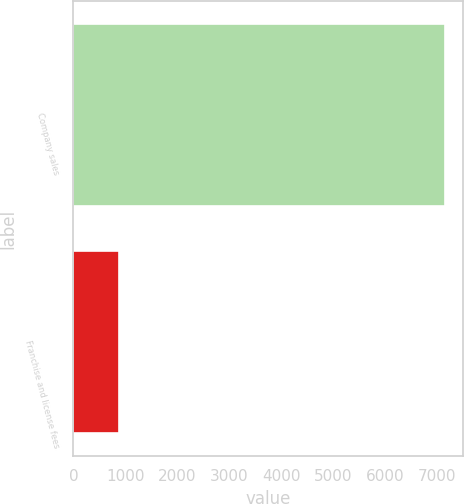<chart> <loc_0><loc_0><loc_500><loc_500><bar_chart><fcel>Company sales<fcel>Franchise and license fees<nl><fcel>7139<fcel>877<nl></chart> 